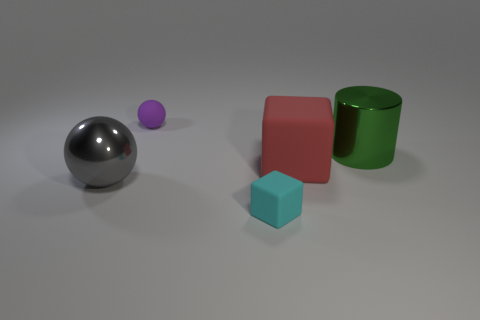Add 3 large green objects. How many objects exist? 8 Subtract all balls. How many objects are left? 3 Subtract 0 green cubes. How many objects are left? 5 Subtract all large gray shiny things. Subtract all spheres. How many objects are left? 2 Add 1 big red rubber things. How many big red rubber things are left? 2 Add 1 small cyan things. How many small cyan things exist? 2 